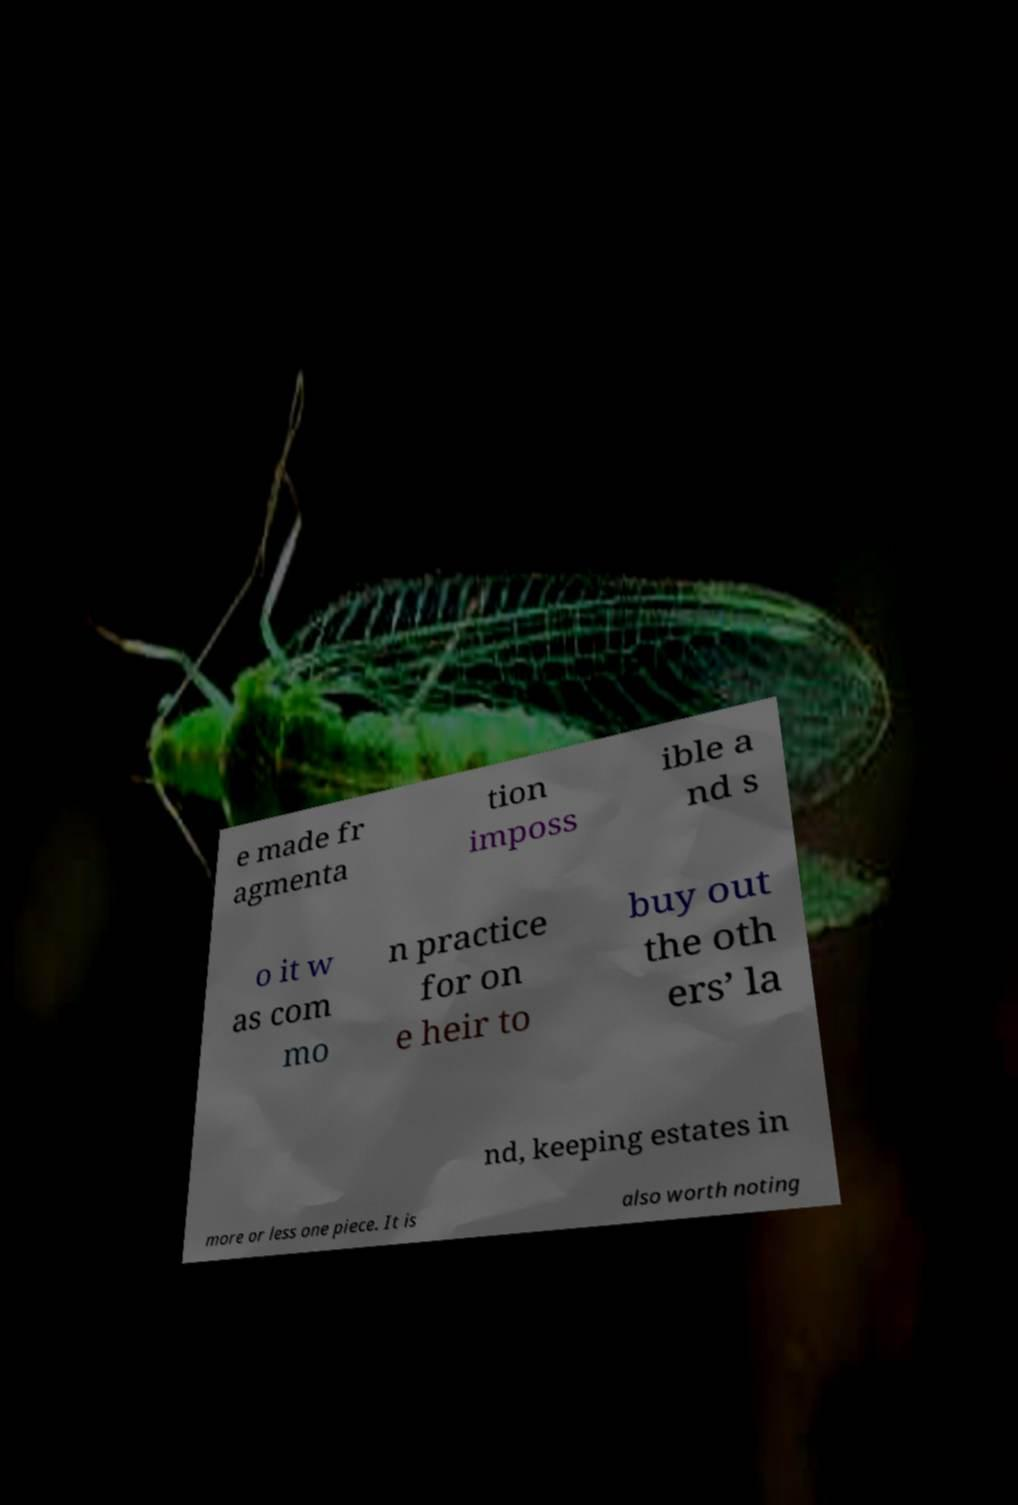Could you assist in decoding the text presented in this image and type it out clearly? e made fr agmenta tion imposs ible a nd s o it w as com mo n practice for on e heir to buy out the oth ers’ la nd, keeping estates in more or less one piece. It is also worth noting 